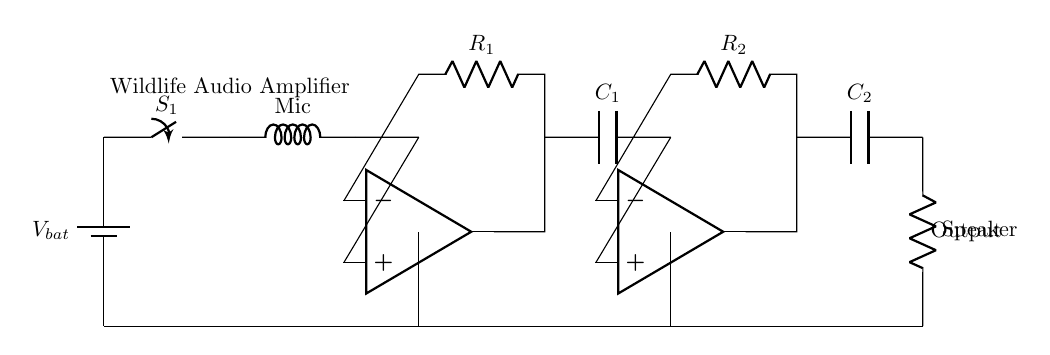What is the function of the microphone? The microphone is used to capture audio from wildlife. It converts sound waves into electrical signals that can be amplified.
Answer: audio capture What components are used for amplification in this circuit? The circuit uses two operational amplifiers labeled as pre-amplifier and main amplifier. These amplifiers boost the electrical signals received from the microphone.
Answer: operational amplifiers What does R1 represent in the circuit? R1 is a resistor that is part of the feedback loop in the pre-amplifier section, which helps control the gain of the amplifier.
Answer: feedback resistor What is the purpose of the capacitor C2? C2 is used in the output stage to block DC signals while allowing AC signals (audio) to pass through to the speaker, facilitating audio output while protecting the speaker.
Answer: DC blocking What is the total number of amplification stages in this circuit? The circuit has two amplification stages: the pre-amplifier stage and the main amplifier stage. Each stage serves to amplify the audio signal sequentially.
Answer: two What type of power supply does this amplifier use? The amplifier is powered by a battery, indicated by the battery symbol at the beginning of the circuit diagram, making it portable for wildlife observation.
Answer: battery What is the final output of this amplifier circuit? The final output of the circuit is sent to a speaker, which produces sound from the amplified audio signals captured by the microphone.
Answer: sound output 